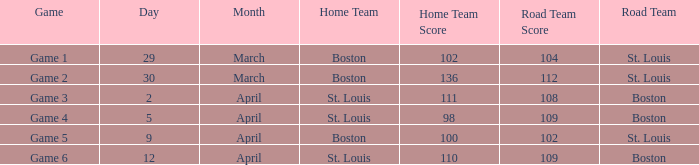What is the Result of Game 3? 111-108. 